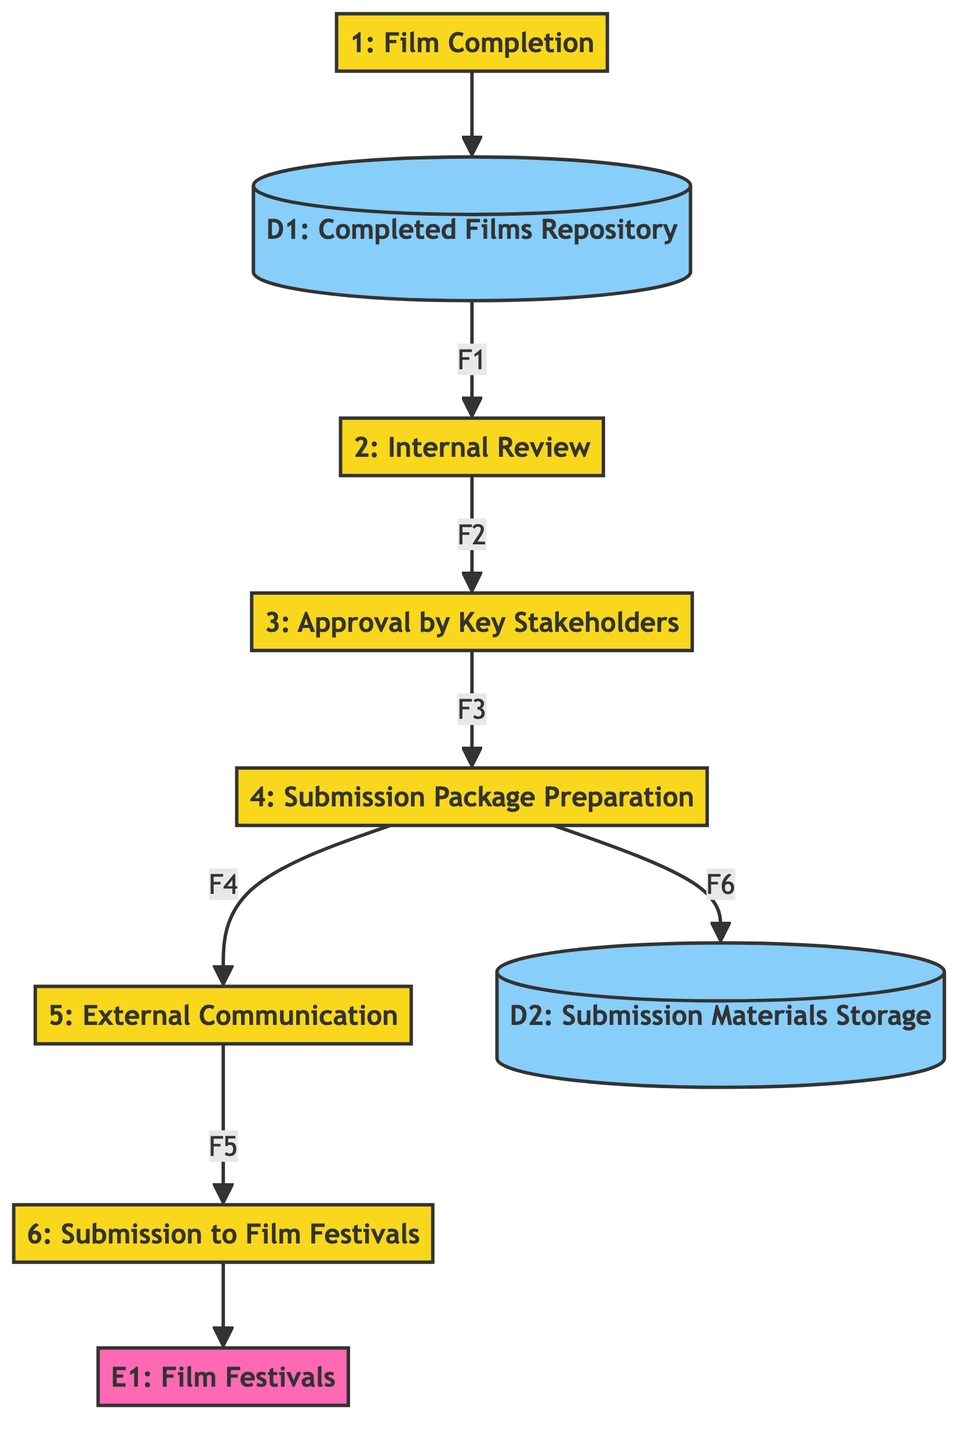What is the first process in the workflow? The first process is 'Film Completion', which starts the workflow after the film is finalized.
Answer: Film Completion How many processes are there in total? There are six processes listed in the diagram representing steps in the submission workflow.
Answer: Six What is stored in the 'Completed Films Repository'? The repository stores all finished films that are ready for internal review, serving as the initial input to the workflow.
Answer: Finished films Which node does the 'Internal Review' process send its output to? The output from 'Internal Review' is sent to 'Approval by Key Stakeholders', indicating the next step in the workflow.
Answer: Approval by Key Stakeholders What is the purpose of 'Submission Package Preparation'? This process prepares the necessary documents and materials to be submitted to film festivals, crucial for the final submission phase.
Answer: Prepare submission materials How does 'External Communication' interact with 'Submission to Film Festivals'? The 'External Communication' sends the final communicated package to 'Submission to Film Festivals', marking the last step in the submission process.
Answer: Sends final package What is the relationship between 'Submission Package Preparation' and 'Submission Materials Storage'? After preparing the submission materials, this process stores those materials in 'Submission Materials Storage' for future reference and organization.
Answer: Store prepared materials Which external entity is involved in the final submission process? The final submission of the film is directed to 'Film Festivals', where the submissions are reviewed by external organizations.
Answer: Film Festivals What happens after 'Approval by Key Stakeholders'? After receiving approval, the film is forwarded to 'Submission Package Preparation' for the necessary documentation to be organized before submission.
Answer: Submission Package Preparation 